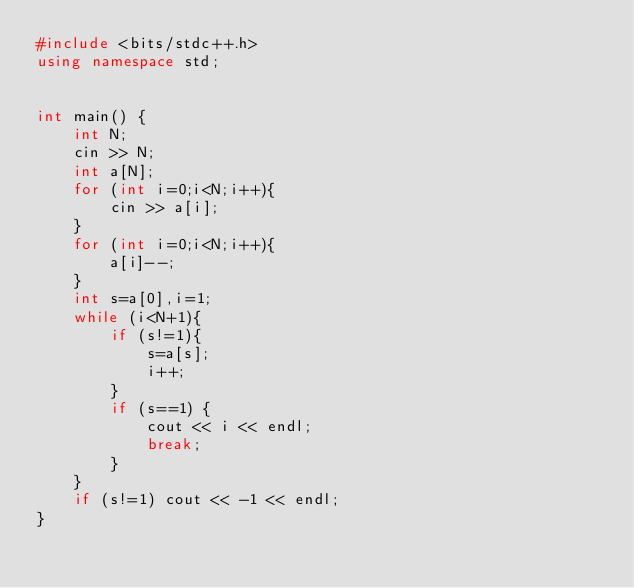<code> <loc_0><loc_0><loc_500><loc_500><_C++_>#include <bits/stdc++.h>
using namespace std;


int main() {
    int N;
    cin >> N;
    int a[N];
    for (int i=0;i<N;i++){
        cin >> a[i];
    }
    for (int i=0;i<N;i++){
        a[i]--;
    }
    int s=a[0],i=1;
    while (i<N+1){
        if (s!=1){
            s=a[s];
            i++;
        }
        if (s==1) {
            cout << i << endl;
            break;
        }
    }
    if (s!=1) cout << -1 << endl;
}
</code> 